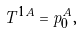Convert formula to latex. <formula><loc_0><loc_0><loc_500><loc_500>T ^ { 1 A } = p _ { 0 } ^ { A } ,</formula> 